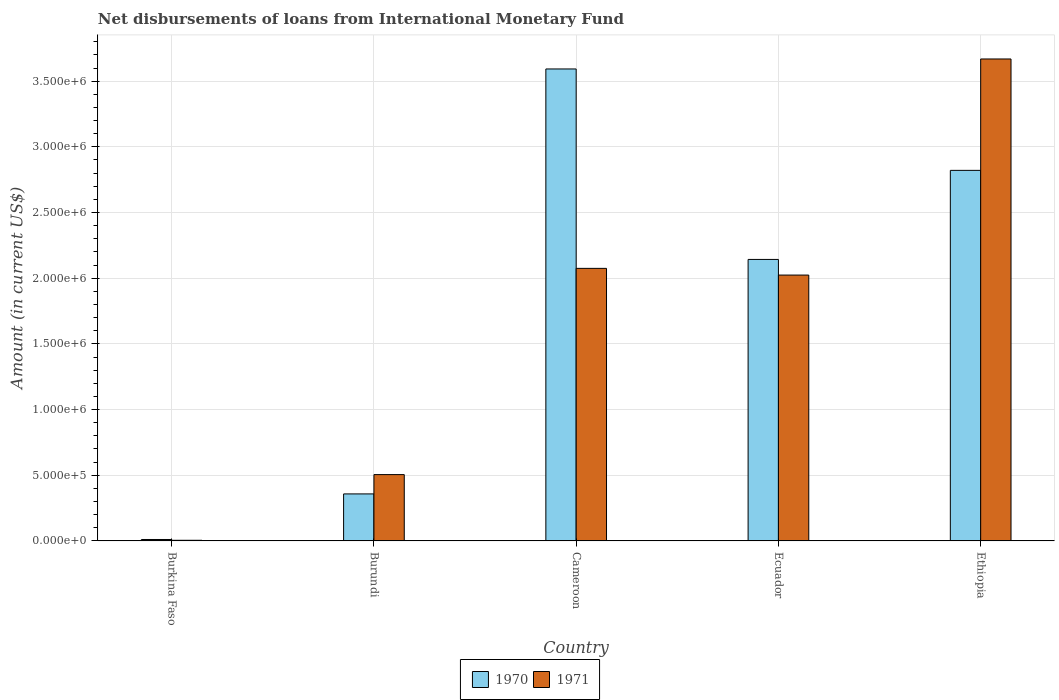How many groups of bars are there?
Provide a short and direct response. 5. Are the number of bars on each tick of the X-axis equal?
Make the answer very short. Yes. How many bars are there on the 5th tick from the right?
Offer a very short reply. 2. What is the label of the 3rd group of bars from the left?
Offer a terse response. Cameroon. In how many cases, is the number of bars for a given country not equal to the number of legend labels?
Ensure brevity in your answer.  0. Across all countries, what is the maximum amount of loans disbursed in 1970?
Give a very brief answer. 3.59e+06. Across all countries, what is the minimum amount of loans disbursed in 1970?
Provide a succinct answer. 1.10e+04. In which country was the amount of loans disbursed in 1971 maximum?
Provide a succinct answer. Ethiopia. In which country was the amount of loans disbursed in 1971 minimum?
Provide a short and direct response. Burkina Faso. What is the total amount of loans disbursed in 1971 in the graph?
Your response must be concise. 8.28e+06. What is the difference between the amount of loans disbursed in 1971 in Burundi and that in Cameroon?
Your response must be concise. -1.57e+06. What is the difference between the amount of loans disbursed in 1970 in Burkina Faso and the amount of loans disbursed in 1971 in Burundi?
Provide a short and direct response. -4.94e+05. What is the average amount of loans disbursed in 1970 per country?
Your answer should be very brief. 1.79e+06. What is the difference between the amount of loans disbursed of/in 1970 and amount of loans disbursed of/in 1971 in Ecuador?
Keep it short and to the point. 1.19e+05. In how many countries, is the amount of loans disbursed in 1970 greater than 2000000 US$?
Provide a succinct answer. 3. What is the ratio of the amount of loans disbursed in 1971 in Cameroon to that in Ethiopia?
Provide a succinct answer. 0.57. Is the amount of loans disbursed in 1971 in Cameroon less than that in Ethiopia?
Make the answer very short. Yes. What is the difference between the highest and the second highest amount of loans disbursed in 1971?
Keep it short and to the point. 1.64e+06. What is the difference between the highest and the lowest amount of loans disbursed in 1971?
Make the answer very short. 3.66e+06. In how many countries, is the amount of loans disbursed in 1971 greater than the average amount of loans disbursed in 1971 taken over all countries?
Provide a succinct answer. 3. Is the sum of the amount of loans disbursed in 1970 in Ecuador and Ethiopia greater than the maximum amount of loans disbursed in 1971 across all countries?
Offer a very short reply. Yes. How many bars are there?
Ensure brevity in your answer.  10. Are all the bars in the graph horizontal?
Keep it short and to the point. No. What is the difference between two consecutive major ticks on the Y-axis?
Provide a succinct answer. 5.00e+05. Are the values on the major ticks of Y-axis written in scientific E-notation?
Your answer should be compact. Yes. Does the graph contain grids?
Ensure brevity in your answer.  Yes. Where does the legend appear in the graph?
Offer a terse response. Bottom center. What is the title of the graph?
Your answer should be very brief. Net disbursements of loans from International Monetary Fund. Does "1977" appear as one of the legend labels in the graph?
Provide a succinct answer. No. What is the label or title of the X-axis?
Give a very brief answer. Country. What is the label or title of the Y-axis?
Ensure brevity in your answer.  Amount (in current US$). What is the Amount (in current US$) of 1970 in Burkina Faso?
Your answer should be very brief. 1.10e+04. What is the Amount (in current US$) of 1970 in Burundi?
Give a very brief answer. 3.58e+05. What is the Amount (in current US$) of 1971 in Burundi?
Offer a terse response. 5.05e+05. What is the Amount (in current US$) of 1970 in Cameroon?
Provide a short and direct response. 3.59e+06. What is the Amount (in current US$) in 1971 in Cameroon?
Provide a short and direct response. 2.08e+06. What is the Amount (in current US$) of 1970 in Ecuador?
Make the answer very short. 2.14e+06. What is the Amount (in current US$) in 1971 in Ecuador?
Make the answer very short. 2.02e+06. What is the Amount (in current US$) of 1970 in Ethiopia?
Your answer should be compact. 2.82e+06. What is the Amount (in current US$) in 1971 in Ethiopia?
Keep it short and to the point. 3.67e+06. Across all countries, what is the maximum Amount (in current US$) of 1970?
Keep it short and to the point. 3.59e+06. Across all countries, what is the maximum Amount (in current US$) of 1971?
Give a very brief answer. 3.67e+06. Across all countries, what is the minimum Amount (in current US$) of 1970?
Your answer should be very brief. 1.10e+04. Across all countries, what is the minimum Amount (in current US$) in 1971?
Offer a terse response. 5000. What is the total Amount (in current US$) of 1970 in the graph?
Make the answer very short. 8.93e+06. What is the total Amount (in current US$) of 1971 in the graph?
Your answer should be compact. 8.28e+06. What is the difference between the Amount (in current US$) of 1970 in Burkina Faso and that in Burundi?
Make the answer very short. -3.47e+05. What is the difference between the Amount (in current US$) in 1971 in Burkina Faso and that in Burundi?
Provide a succinct answer. -5.00e+05. What is the difference between the Amount (in current US$) of 1970 in Burkina Faso and that in Cameroon?
Your answer should be compact. -3.58e+06. What is the difference between the Amount (in current US$) of 1971 in Burkina Faso and that in Cameroon?
Give a very brief answer. -2.07e+06. What is the difference between the Amount (in current US$) in 1970 in Burkina Faso and that in Ecuador?
Provide a short and direct response. -2.13e+06. What is the difference between the Amount (in current US$) of 1971 in Burkina Faso and that in Ecuador?
Offer a very short reply. -2.02e+06. What is the difference between the Amount (in current US$) of 1970 in Burkina Faso and that in Ethiopia?
Provide a succinct answer. -2.81e+06. What is the difference between the Amount (in current US$) in 1971 in Burkina Faso and that in Ethiopia?
Your answer should be compact. -3.66e+06. What is the difference between the Amount (in current US$) in 1970 in Burundi and that in Cameroon?
Your answer should be very brief. -3.24e+06. What is the difference between the Amount (in current US$) of 1971 in Burundi and that in Cameroon?
Offer a very short reply. -1.57e+06. What is the difference between the Amount (in current US$) of 1970 in Burundi and that in Ecuador?
Offer a terse response. -1.78e+06. What is the difference between the Amount (in current US$) of 1971 in Burundi and that in Ecuador?
Make the answer very short. -1.52e+06. What is the difference between the Amount (in current US$) of 1970 in Burundi and that in Ethiopia?
Make the answer very short. -2.46e+06. What is the difference between the Amount (in current US$) of 1971 in Burundi and that in Ethiopia?
Provide a short and direct response. -3.16e+06. What is the difference between the Amount (in current US$) in 1970 in Cameroon and that in Ecuador?
Keep it short and to the point. 1.45e+06. What is the difference between the Amount (in current US$) of 1971 in Cameroon and that in Ecuador?
Your response must be concise. 5.10e+04. What is the difference between the Amount (in current US$) of 1970 in Cameroon and that in Ethiopia?
Offer a terse response. 7.72e+05. What is the difference between the Amount (in current US$) in 1971 in Cameroon and that in Ethiopia?
Make the answer very short. -1.59e+06. What is the difference between the Amount (in current US$) of 1970 in Ecuador and that in Ethiopia?
Offer a terse response. -6.78e+05. What is the difference between the Amount (in current US$) of 1971 in Ecuador and that in Ethiopia?
Ensure brevity in your answer.  -1.64e+06. What is the difference between the Amount (in current US$) of 1970 in Burkina Faso and the Amount (in current US$) of 1971 in Burundi?
Provide a succinct answer. -4.94e+05. What is the difference between the Amount (in current US$) of 1970 in Burkina Faso and the Amount (in current US$) of 1971 in Cameroon?
Provide a short and direct response. -2.06e+06. What is the difference between the Amount (in current US$) of 1970 in Burkina Faso and the Amount (in current US$) of 1971 in Ecuador?
Keep it short and to the point. -2.01e+06. What is the difference between the Amount (in current US$) in 1970 in Burkina Faso and the Amount (in current US$) in 1971 in Ethiopia?
Offer a terse response. -3.66e+06. What is the difference between the Amount (in current US$) of 1970 in Burundi and the Amount (in current US$) of 1971 in Cameroon?
Your answer should be compact. -1.72e+06. What is the difference between the Amount (in current US$) of 1970 in Burundi and the Amount (in current US$) of 1971 in Ecuador?
Make the answer very short. -1.67e+06. What is the difference between the Amount (in current US$) of 1970 in Burundi and the Amount (in current US$) of 1971 in Ethiopia?
Provide a succinct answer. -3.31e+06. What is the difference between the Amount (in current US$) in 1970 in Cameroon and the Amount (in current US$) in 1971 in Ecuador?
Provide a succinct answer. 1.57e+06. What is the difference between the Amount (in current US$) in 1970 in Cameroon and the Amount (in current US$) in 1971 in Ethiopia?
Keep it short and to the point. -7.60e+04. What is the difference between the Amount (in current US$) in 1970 in Ecuador and the Amount (in current US$) in 1971 in Ethiopia?
Offer a terse response. -1.53e+06. What is the average Amount (in current US$) in 1970 per country?
Offer a terse response. 1.79e+06. What is the average Amount (in current US$) in 1971 per country?
Your answer should be compact. 1.66e+06. What is the difference between the Amount (in current US$) in 1970 and Amount (in current US$) in 1971 in Burkina Faso?
Your answer should be compact. 6000. What is the difference between the Amount (in current US$) in 1970 and Amount (in current US$) in 1971 in Burundi?
Your response must be concise. -1.47e+05. What is the difference between the Amount (in current US$) in 1970 and Amount (in current US$) in 1971 in Cameroon?
Ensure brevity in your answer.  1.52e+06. What is the difference between the Amount (in current US$) of 1970 and Amount (in current US$) of 1971 in Ecuador?
Offer a terse response. 1.19e+05. What is the difference between the Amount (in current US$) in 1970 and Amount (in current US$) in 1971 in Ethiopia?
Your answer should be compact. -8.48e+05. What is the ratio of the Amount (in current US$) of 1970 in Burkina Faso to that in Burundi?
Make the answer very short. 0.03. What is the ratio of the Amount (in current US$) of 1971 in Burkina Faso to that in Burundi?
Your answer should be very brief. 0.01. What is the ratio of the Amount (in current US$) in 1970 in Burkina Faso to that in Cameroon?
Provide a short and direct response. 0. What is the ratio of the Amount (in current US$) in 1971 in Burkina Faso to that in Cameroon?
Provide a short and direct response. 0. What is the ratio of the Amount (in current US$) in 1970 in Burkina Faso to that in Ecuador?
Offer a terse response. 0.01. What is the ratio of the Amount (in current US$) in 1971 in Burkina Faso to that in Ecuador?
Provide a short and direct response. 0. What is the ratio of the Amount (in current US$) of 1970 in Burkina Faso to that in Ethiopia?
Your answer should be very brief. 0. What is the ratio of the Amount (in current US$) in 1971 in Burkina Faso to that in Ethiopia?
Give a very brief answer. 0. What is the ratio of the Amount (in current US$) in 1970 in Burundi to that in Cameroon?
Provide a short and direct response. 0.1. What is the ratio of the Amount (in current US$) in 1971 in Burundi to that in Cameroon?
Provide a succinct answer. 0.24. What is the ratio of the Amount (in current US$) of 1970 in Burundi to that in Ecuador?
Keep it short and to the point. 0.17. What is the ratio of the Amount (in current US$) of 1971 in Burundi to that in Ecuador?
Provide a succinct answer. 0.25. What is the ratio of the Amount (in current US$) of 1970 in Burundi to that in Ethiopia?
Offer a very short reply. 0.13. What is the ratio of the Amount (in current US$) of 1971 in Burundi to that in Ethiopia?
Give a very brief answer. 0.14. What is the ratio of the Amount (in current US$) of 1970 in Cameroon to that in Ecuador?
Give a very brief answer. 1.68. What is the ratio of the Amount (in current US$) of 1971 in Cameroon to that in Ecuador?
Make the answer very short. 1.03. What is the ratio of the Amount (in current US$) in 1970 in Cameroon to that in Ethiopia?
Make the answer very short. 1.27. What is the ratio of the Amount (in current US$) of 1971 in Cameroon to that in Ethiopia?
Offer a very short reply. 0.57. What is the ratio of the Amount (in current US$) in 1970 in Ecuador to that in Ethiopia?
Your answer should be very brief. 0.76. What is the ratio of the Amount (in current US$) in 1971 in Ecuador to that in Ethiopia?
Give a very brief answer. 0.55. What is the difference between the highest and the second highest Amount (in current US$) of 1970?
Offer a terse response. 7.72e+05. What is the difference between the highest and the second highest Amount (in current US$) in 1971?
Your response must be concise. 1.59e+06. What is the difference between the highest and the lowest Amount (in current US$) of 1970?
Make the answer very short. 3.58e+06. What is the difference between the highest and the lowest Amount (in current US$) of 1971?
Give a very brief answer. 3.66e+06. 